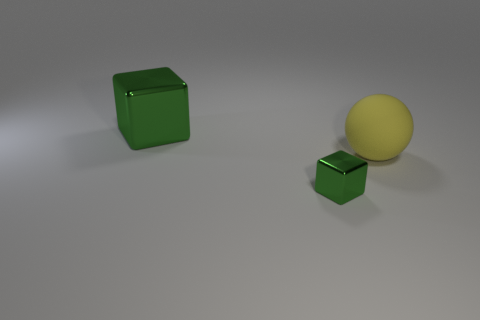Add 1 big metallic things. How many objects exist? 4 Subtract all cubes. How many objects are left? 1 Subtract 1 spheres. How many spheres are left? 0 Subtract all brown balls. How many brown blocks are left? 0 Add 1 large metal blocks. How many large metal blocks are left? 2 Add 2 large gray metal things. How many large gray metal things exist? 2 Subtract 1 yellow spheres. How many objects are left? 2 Subtract all cyan balls. Subtract all blue cylinders. How many balls are left? 1 Subtract all big cyan rubber spheres. Subtract all shiny things. How many objects are left? 1 